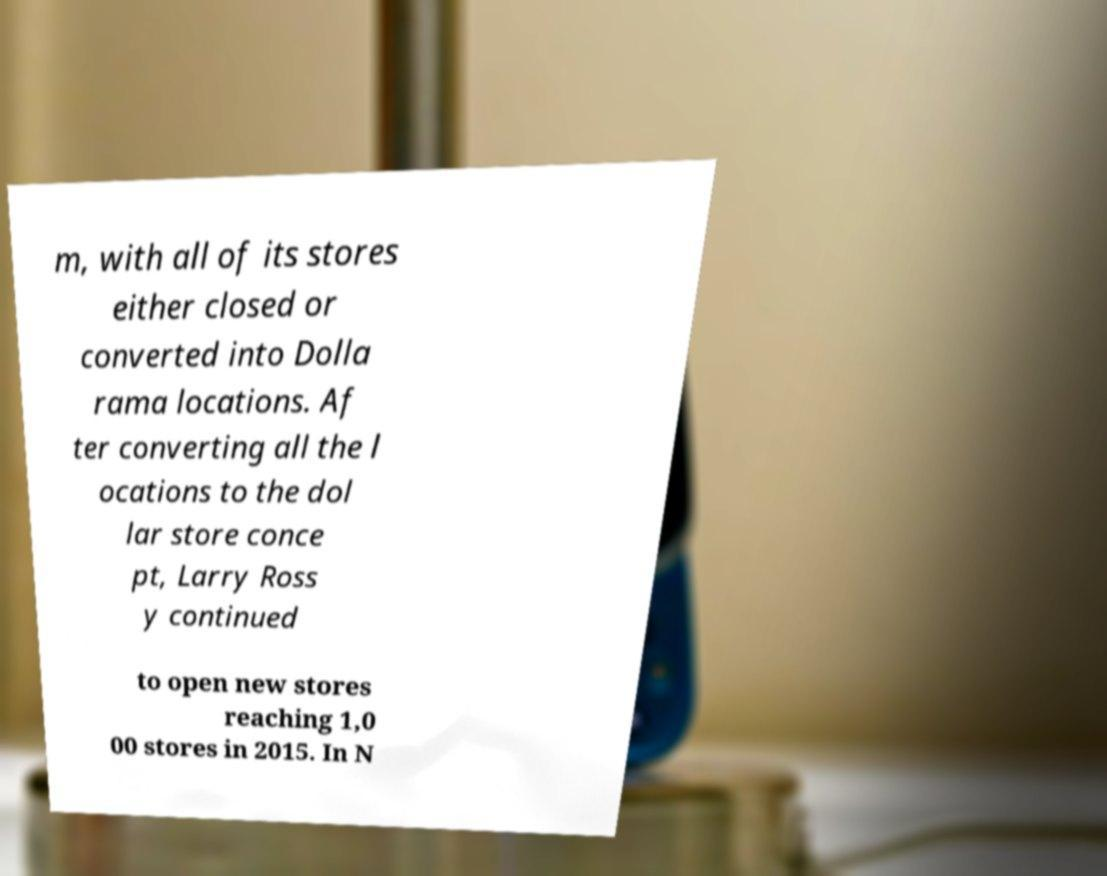What messages or text are displayed in this image? I need them in a readable, typed format. m, with all of its stores either closed or converted into Dolla rama locations. Af ter converting all the l ocations to the dol lar store conce pt, Larry Ross y continued to open new stores reaching 1,0 00 stores in 2015. In N 